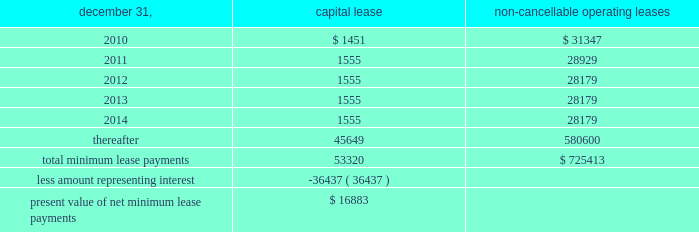Notes to consolidated financial statements of annual compensation was made .
For the years ended december 31 , 2009 , 2008 and , 2007 , we made matching contributions of approxi- mately $ 450000 , $ 503000 and $ 457000 , respectively .
Note 17 / commitments and contingencies we and our operating partnership are not presently involved in any mate- rial litigation nor , to our knowledge , is any material litigation threatened against us or our properties , other than routine litigation arising in the ordinary course of business .
Management believes the costs , if any , incurred by us and our operating partnership related to this litigation will not materially affect our financial position , operating results or liquidity .
We have entered into employment agreements with certain executives , which expire between june 2010 and january 2013 .
The minimum cash-based compensation , including base salary and guaran- teed bonus payments , associated with these employment agreements totals approximately $ 7.8 million for 2010 .
In march 1998 , we acquired an operating sub-leasehold posi- tion at 420 lexington avenue .
The operating sub-leasehold position required annual ground lease payments totaling $ 6.0 million and sub- leasehold position payments totaling $ 1.1 million ( excluding an operating sub-lease position purchased january 1999 ) .
In june 2007 , we renewed and extended the maturity date of the ground lease at 420 lexington avenue through december 31 , 2029 , with an option for further exten- sion through 2080 .
Ground lease rent payments through 2029 will total approximately $ 10.9 million per year .
Thereafter , the ground lease will be subject to a revaluation by the parties thereto .
In june 2009 , we acquired an operating sub-leasehold posi- tion at 420 lexington avenue for approximately $ 7.7 million .
These sub-leasehold positions were scheduled to mature in december 2029 .
In october 2009 , we acquired the remaining sub-leasehold position for $ 7.6 million .
The property located at 711 third avenue operates under an operating sub-lease , which expires in 2083 .
Under the sub-lease , we are responsible for ground rent payments of $ 1.55 million annually through july 2011 on the 50% ( 50 % ) portion of the fee we do not own .
The ground rent is reset after july 2011 based on the estimated fair market value of the property .
We have an option to buy out the sub-lease at a fixed future date .
The property located at 461 fifth avenue operates under a ground lease ( approximately $ 2.1 million annually ) with a term expiration date of 2027 and with two options to renew for an additional 21 years each , followed by a third option for 15 years .
We also have an option to purchase the ground lease for a fixed price on a specific date .
The property located at 625 madison avenue operates under a ground lease ( approximately $ 4.6 million annually ) with a term expiration date of 2022 and with two options to renew for an additional 23 years .
The property located at 1185 avenue of the americas oper- ates under a ground lease ( approximately $ 8.5 million in 2010 and $ 6.9 million annually thereafter ) with a term expiration of 2020 and with an option to renew for an additional 23 years .
In april 1988 , the sl green predecessor entered into a lease agreement for the property at 673 first avenue , which has been capitalized for financial statement purposes .
Land was estimated to be approximately 70% ( 70 % ) of the fair market value of the property .
The portion of the lease attributed to land is classified as an operating lease and the remainder as a capital lease .
The initial lease term is 49 years with an option for an additional 26 years .
Beginning in lease years 11 and 25 , the lessor is entitled to additional rent as defined by the lease agreement .
We continue to lease the 673 first avenue property , which has been classified as a capital lease with a cost basis of $ 12.2 million and cumulative amortization of $ 5.5 million and $ 5.2 million at december 31 , 2009 and 2008 , respectively .
The following is a schedule of future minimum lease payments under capital leases and noncancellable operating leases with initial terms in excess of one year as of december 31 , 2009 ( in thousands ) : non-cancellable december 31 , capital lease operating leases .
Note 18 / financial instruments : derivatives and hedging we recognize all derivatives on the balance sheet at fair value .
Derivatives that are not hedges must be adjusted to fair value through income .
If a derivative is a hedge , depending on the nature of the hedge , changes in the fair value of the derivative will either be offset against the change in fair value of the hedged asset , liability , or firm commitment through earn- ings , or recognized in other comprehensive income until the hedged item is recognized in earnings .
The ineffective portion of a derivative 2019s change in fair value will be immediately recognized in earnings .
Reported net income and stockholders 2019 equity may increase or decrease prospectively , depending on future levels of interest rates and other variables affecting the fair values of derivative instruments and hedged items , but will have no effect on cash flows. .
What was the change in non-cancellable operating lease expense in millions between 2011 and 2012? 
Computations: (28929 - 28179)
Answer: 750.0. 